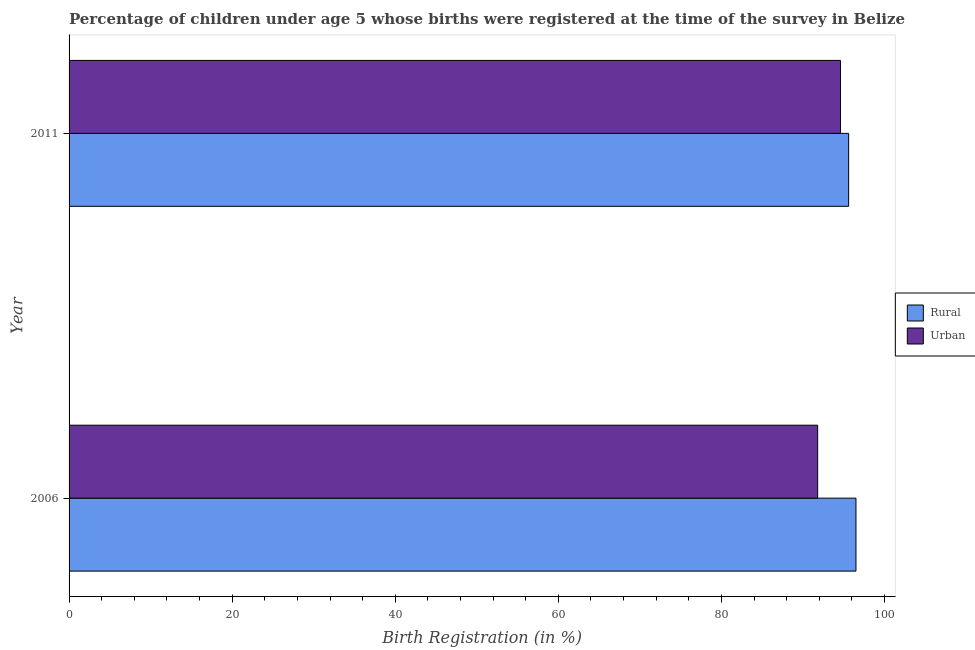How many different coloured bars are there?
Your answer should be very brief. 2. Are the number of bars on each tick of the Y-axis equal?
Your answer should be very brief. Yes. How many bars are there on the 1st tick from the top?
Your answer should be compact. 2. What is the rural birth registration in 2006?
Your response must be concise. 96.5. Across all years, what is the maximum urban birth registration?
Offer a very short reply. 94.6. Across all years, what is the minimum rural birth registration?
Ensure brevity in your answer.  95.6. In which year was the rural birth registration maximum?
Offer a terse response. 2006. What is the total rural birth registration in the graph?
Make the answer very short. 192.1. What is the difference between the rural birth registration in 2006 and the urban birth registration in 2011?
Offer a terse response. 1.9. What is the average urban birth registration per year?
Offer a terse response. 93.2. In the year 2011, what is the difference between the urban birth registration and rural birth registration?
Your answer should be very brief. -1. What is the ratio of the urban birth registration in 2006 to that in 2011?
Your answer should be very brief. 0.97. Is the difference between the urban birth registration in 2006 and 2011 greater than the difference between the rural birth registration in 2006 and 2011?
Your answer should be very brief. No. In how many years, is the urban birth registration greater than the average urban birth registration taken over all years?
Your answer should be very brief. 1. What does the 1st bar from the top in 2011 represents?
Provide a short and direct response. Urban. What does the 2nd bar from the bottom in 2011 represents?
Provide a succinct answer. Urban. Are all the bars in the graph horizontal?
Your response must be concise. Yes. How many legend labels are there?
Offer a terse response. 2. How are the legend labels stacked?
Give a very brief answer. Vertical. What is the title of the graph?
Provide a succinct answer. Percentage of children under age 5 whose births were registered at the time of the survey in Belize. Does "Under-five" appear as one of the legend labels in the graph?
Ensure brevity in your answer.  No. What is the label or title of the X-axis?
Give a very brief answer. Birth Registration (in %). What is the Birth Registration (in %) of Rural in 2006?
Offer a very short reply. 96.5. What is the Birth Registration (in %) in Urban in 2006?
Give a very brief answer. 91.8. What is the Birth Registration (in %) in Rural in 2011?
Offer a very short reply. 95.6. What is the Birth Registration (in %) in Urban in 2011?
Provide a succinct answer. 94.6. Across all years, what is the maximum Birth Registration (in %) of Rural?
Provide a succinct answer. 96.5. Across all years, what is the maximum Birth Registration (in %) in Urban?
Ensure brevity in your answer.  94.6. Across all years, what is the minimum Birth Registration (in %) in Rural?
Your response must be concise. 95.6. Across all years, what is the minimum Birth Registration (in %) in Urban?
Offer a very short reply. 91.8. What is the total Birth Registration (in %) of Rural in the graph?
Offer a very short reply. 192.1. What is the total Birth Registration (in %) in Urban in the graph?
Keep it short and to the point. 186.4. What is the average Birth Registration (in %) of Rural per year?
Ensure brevity in your answer.  96.05. What is the average Birth Registration (in %) in Urban per year?
Keep it short and to the point. 93.2. In the year 2011, what is the difference between the Birth Registration (in %) of Rural and Birth Registration (in %) of Urban?
Your response must be concise. 1. What is the ratio of the Birth Registration (in %) of Rural in 2006 to that in 2011?
Your answer should be compact. 1.01. What is the ratio of the Birth Registration (in %) in Urban in 2006 to that in 2011?
Your response must be concise. 0.97. What is the difference between the highest and the second highest Birth Registration (in %) of Rural?
Ensure brevity in your answer.  0.9. What is the difference between the highest and the second highest Birth Registration (in %) of Urban?
Offer a very short reply. 2.8. What is the difference between the highest and the lowest Birth Registration (in %) of Rural?
Give a very brief answer. 0.9. What is the difference between the highest and the lowest Birth Registration (in %) of Urban?
Give a very brief answer. 2.8. 